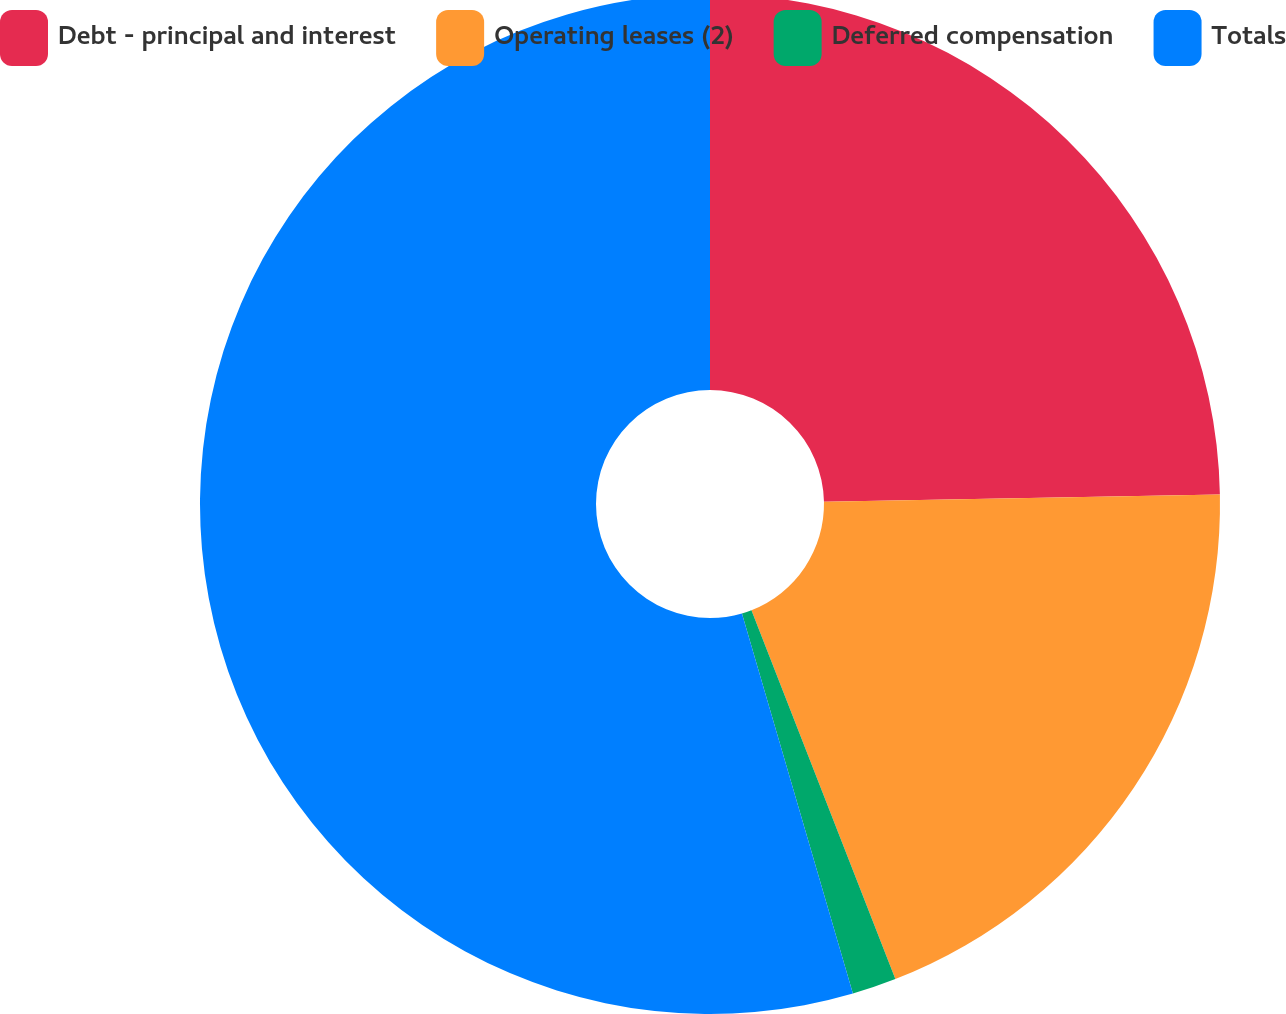Convert chart. <chart><loc_0><loc_0><loc_500><loc_500><pie_chart><fcel>Debt - principal and interest<fcel>Operating leases (2)<fcel>Deferred compensation<fcel>Totals<nl><fcel>24.7%<fcel>19.38%<fcel>1.4%<fcel>54.52%<nl></chart> 